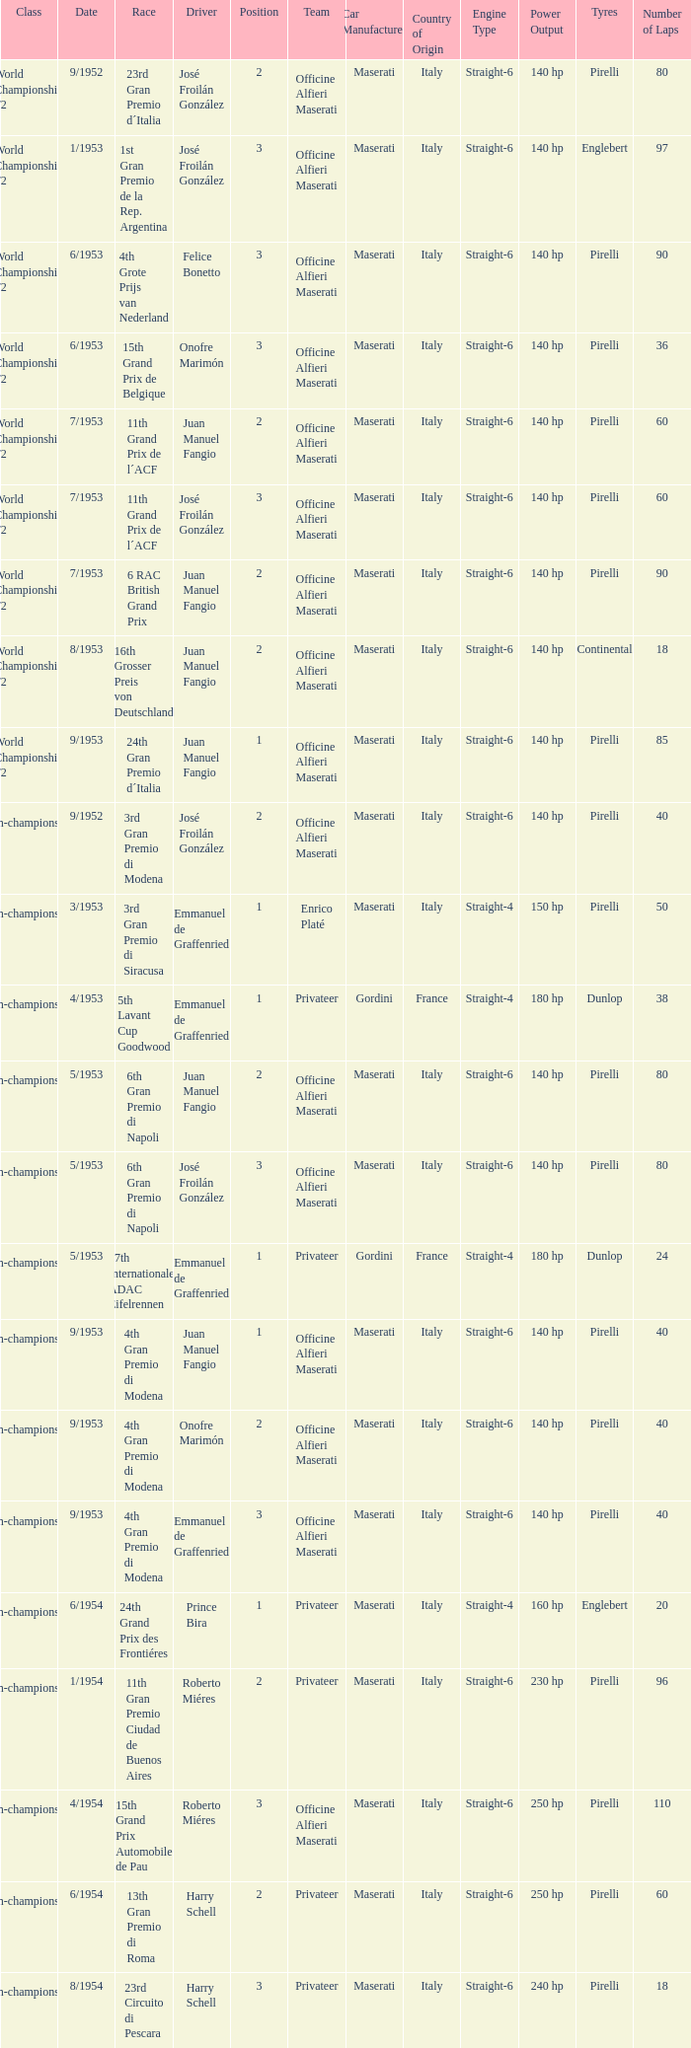What driver has a team of officine alfieri maserati and belongs to the class of non-championship f2 and has a position of 2, as well as a date of 9/1952? José Froilán González. 